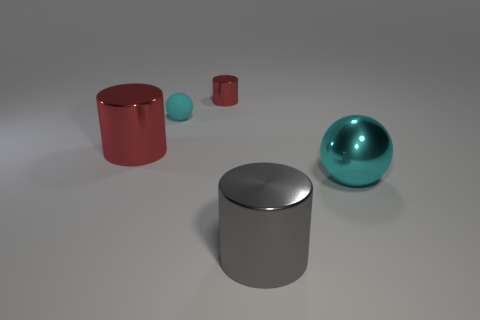The big cylinder that is on the left side of the large object that is in front of the cyan object right of the big gray shiny cylinder is what color?
Your answer should be compact. Red. There is a large sphere that is the same material as the small cylinder; what is its color?
Provide a short and direct response. Cyan. What number of cylinders are the same material as the big gray object?
Provide a succinct answer. 2. There is a cyan sphere on the left side of the cyan shiny object; does it have the same size as the big gray cylinder?
Your answer should be compact. No. What is the color of the metal sphere that is the same size as the gray cylinder?
Provide a short and direct response. Cyan. There is a small shiny cylinder; what number of objects are in front of it?
Offer a terse response. 4. Are any cyan spheres visible?
Provide a short and direct response. Yes. There is a red cylinder that is left of the cyan object left of the shiny cylinder behind the large red metallic object; how big is it?
Keep it short and to the point. Large. How many other things are the same size as the cyan metallic ball?
Your answer should be very brief. 2. How big is the red metal cylinder that is behind the big red cylinder?
Provide a succinct answer. Small. 